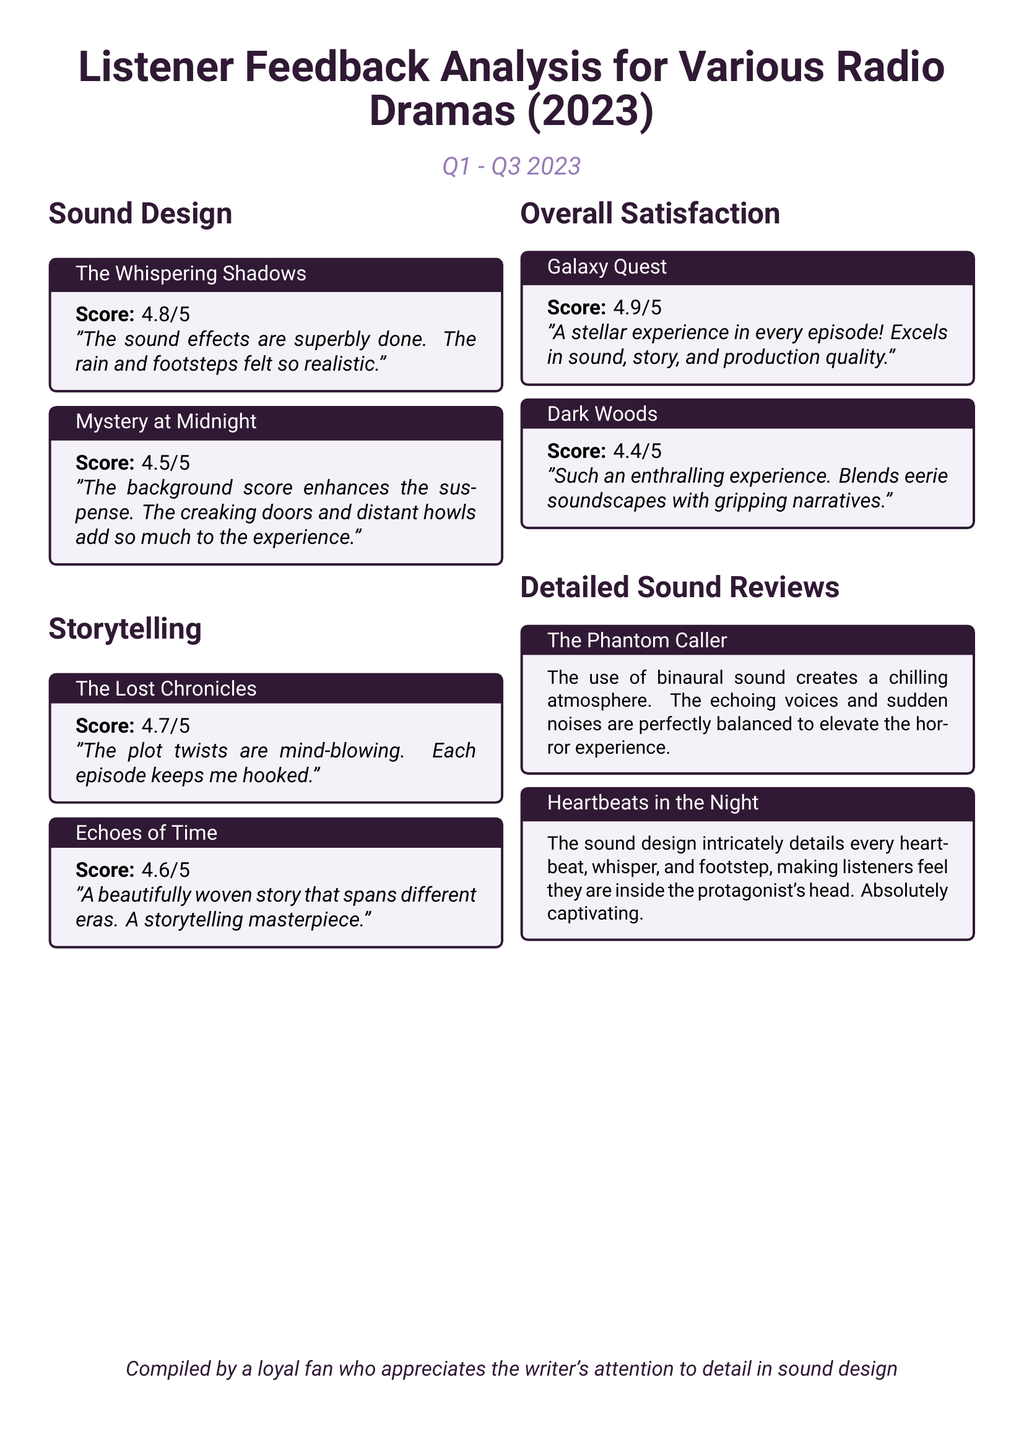What is the score for The Whispering Shadows? The score for The Whispering Shadows is stated in the scorecard as 4.8 out of 5.
Answer: 4.8/5 What radio drama received a score of 4.9? The scorecard lists Galaxy Quest as having a score of 4.9 out of 5.
Answer: Galaxy Quest How many titles are categorized under Sound Design? The document shows a total of 2 radio dramas under the Sound Design category.
Answer: 2 Which drama is noted for its intricate heartbeat sound design? The analysis mentions Heartbeats in the Night for its detailed sound design including heartbeats.
Answer: Heartbeats in the Night What is the score for Dark Woods? The score assigned to Dark Woods is shown as 4.4 out of 5.
Answer: 4.4/5 Which radio drama features "echoing voices and sudden noises"? The Phantom Caller is noted for its chilling atmosphere created by echoing voices and sudden noises.
Answer: The Phantom Caller What is the theme of the sound design in Mystery at Midnight? The document highlights suspense as the theme of sound design in Mystery at Midnight.
Answer: Suspense How does Galaxy Quest rank in terms of overall satisfaction? Galaxy Quest is rated 4.9/5, indicating high overall satisfaction among listeners.
Answer: 4.9/5 